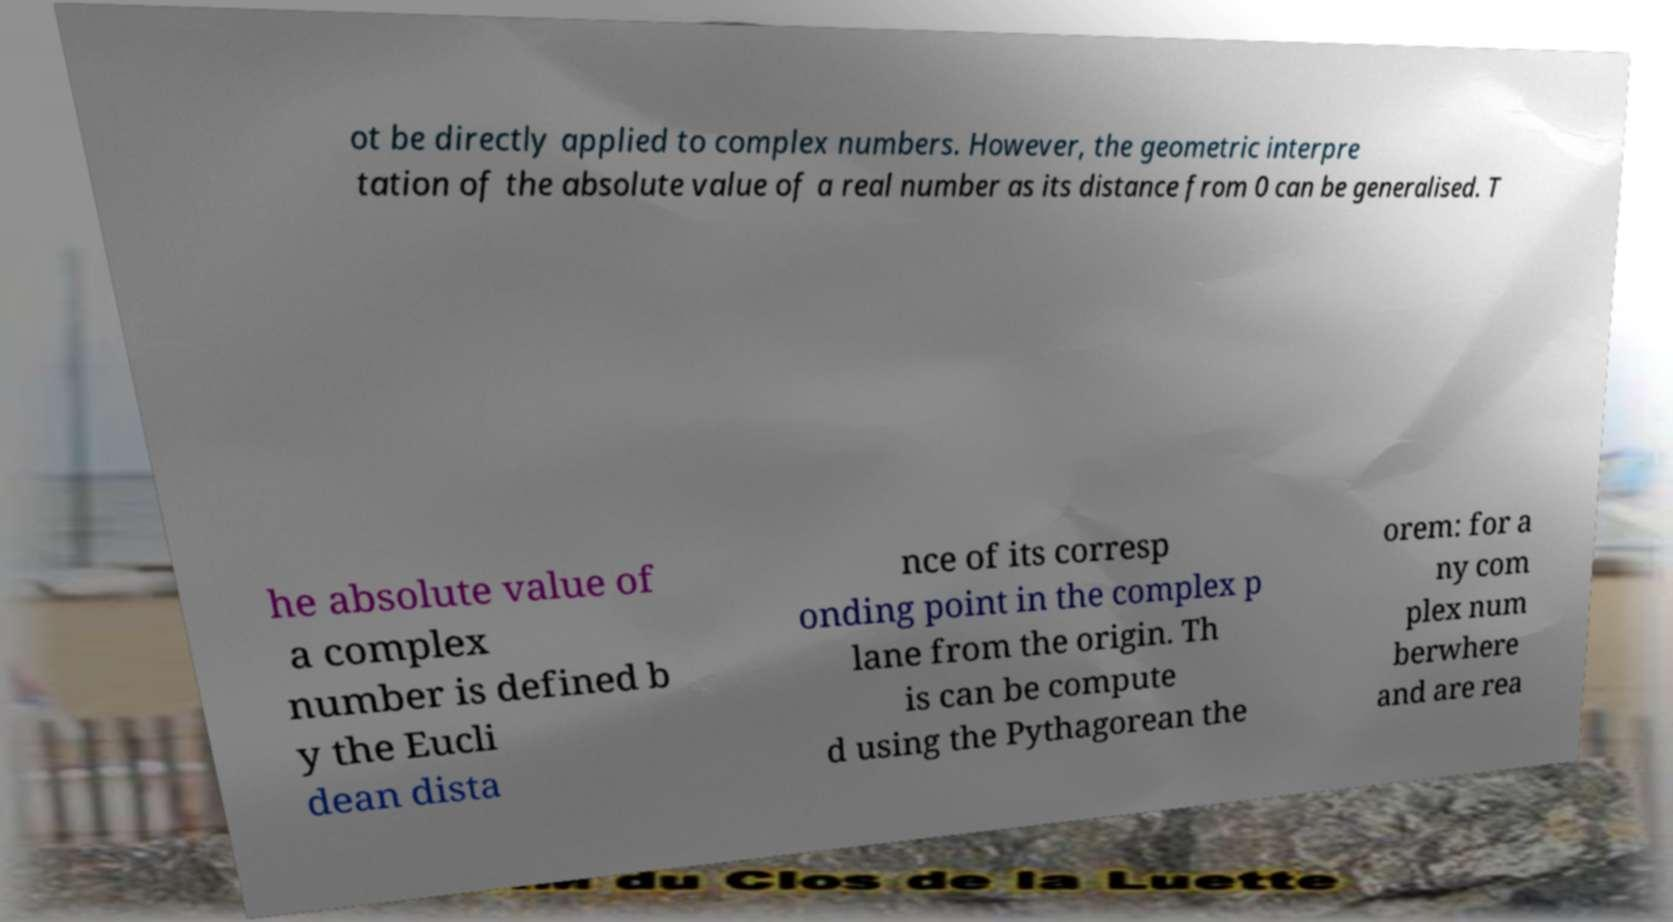For documentation purposes, I need the text within this image transcribed. Could you provide that? ot be directly applied to complex numbers. However, the geometric interpre tation of the absolute value of a real number as its distance from 0 can be generalised. T he absolute value of a complex number is defined b y the Eucli dean dista nce of its corresp onding point in the complex p lane from the origin. Th is can be compute d using the Pythagorean the orem: for a ny com plex num berwhere and are rea 